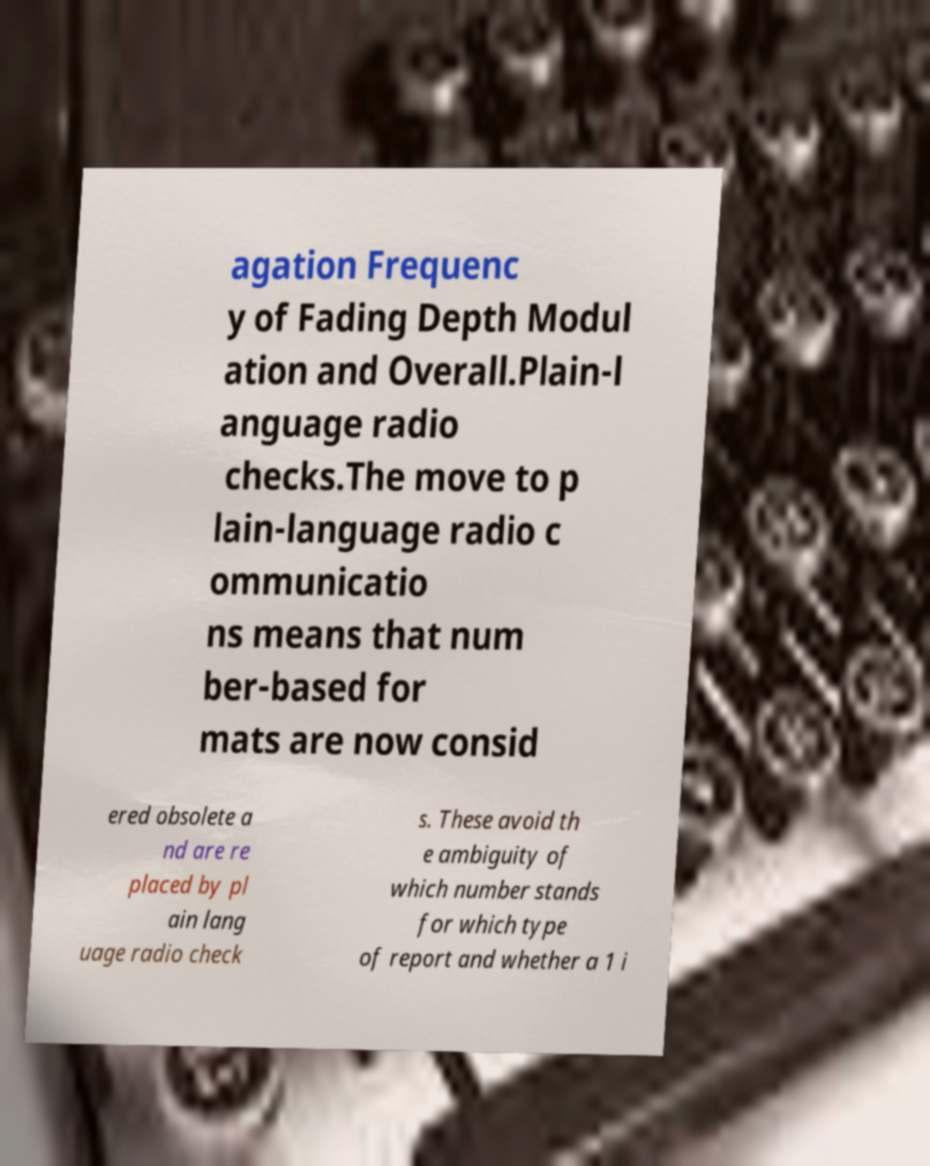Could you extract and type out the text from this image? agation Frequenc y of Fading Depth Modul ation and Overall.Plain-l anguage radio checks.The move to p lain-language radio c ommunicatio ns means that num ber-based for mats are now consid ered obsolete a nd are re placed by pl ain lang uage radio check s. These avoid th e ambiguity of which number stands for which type of report and whether a 1 i 